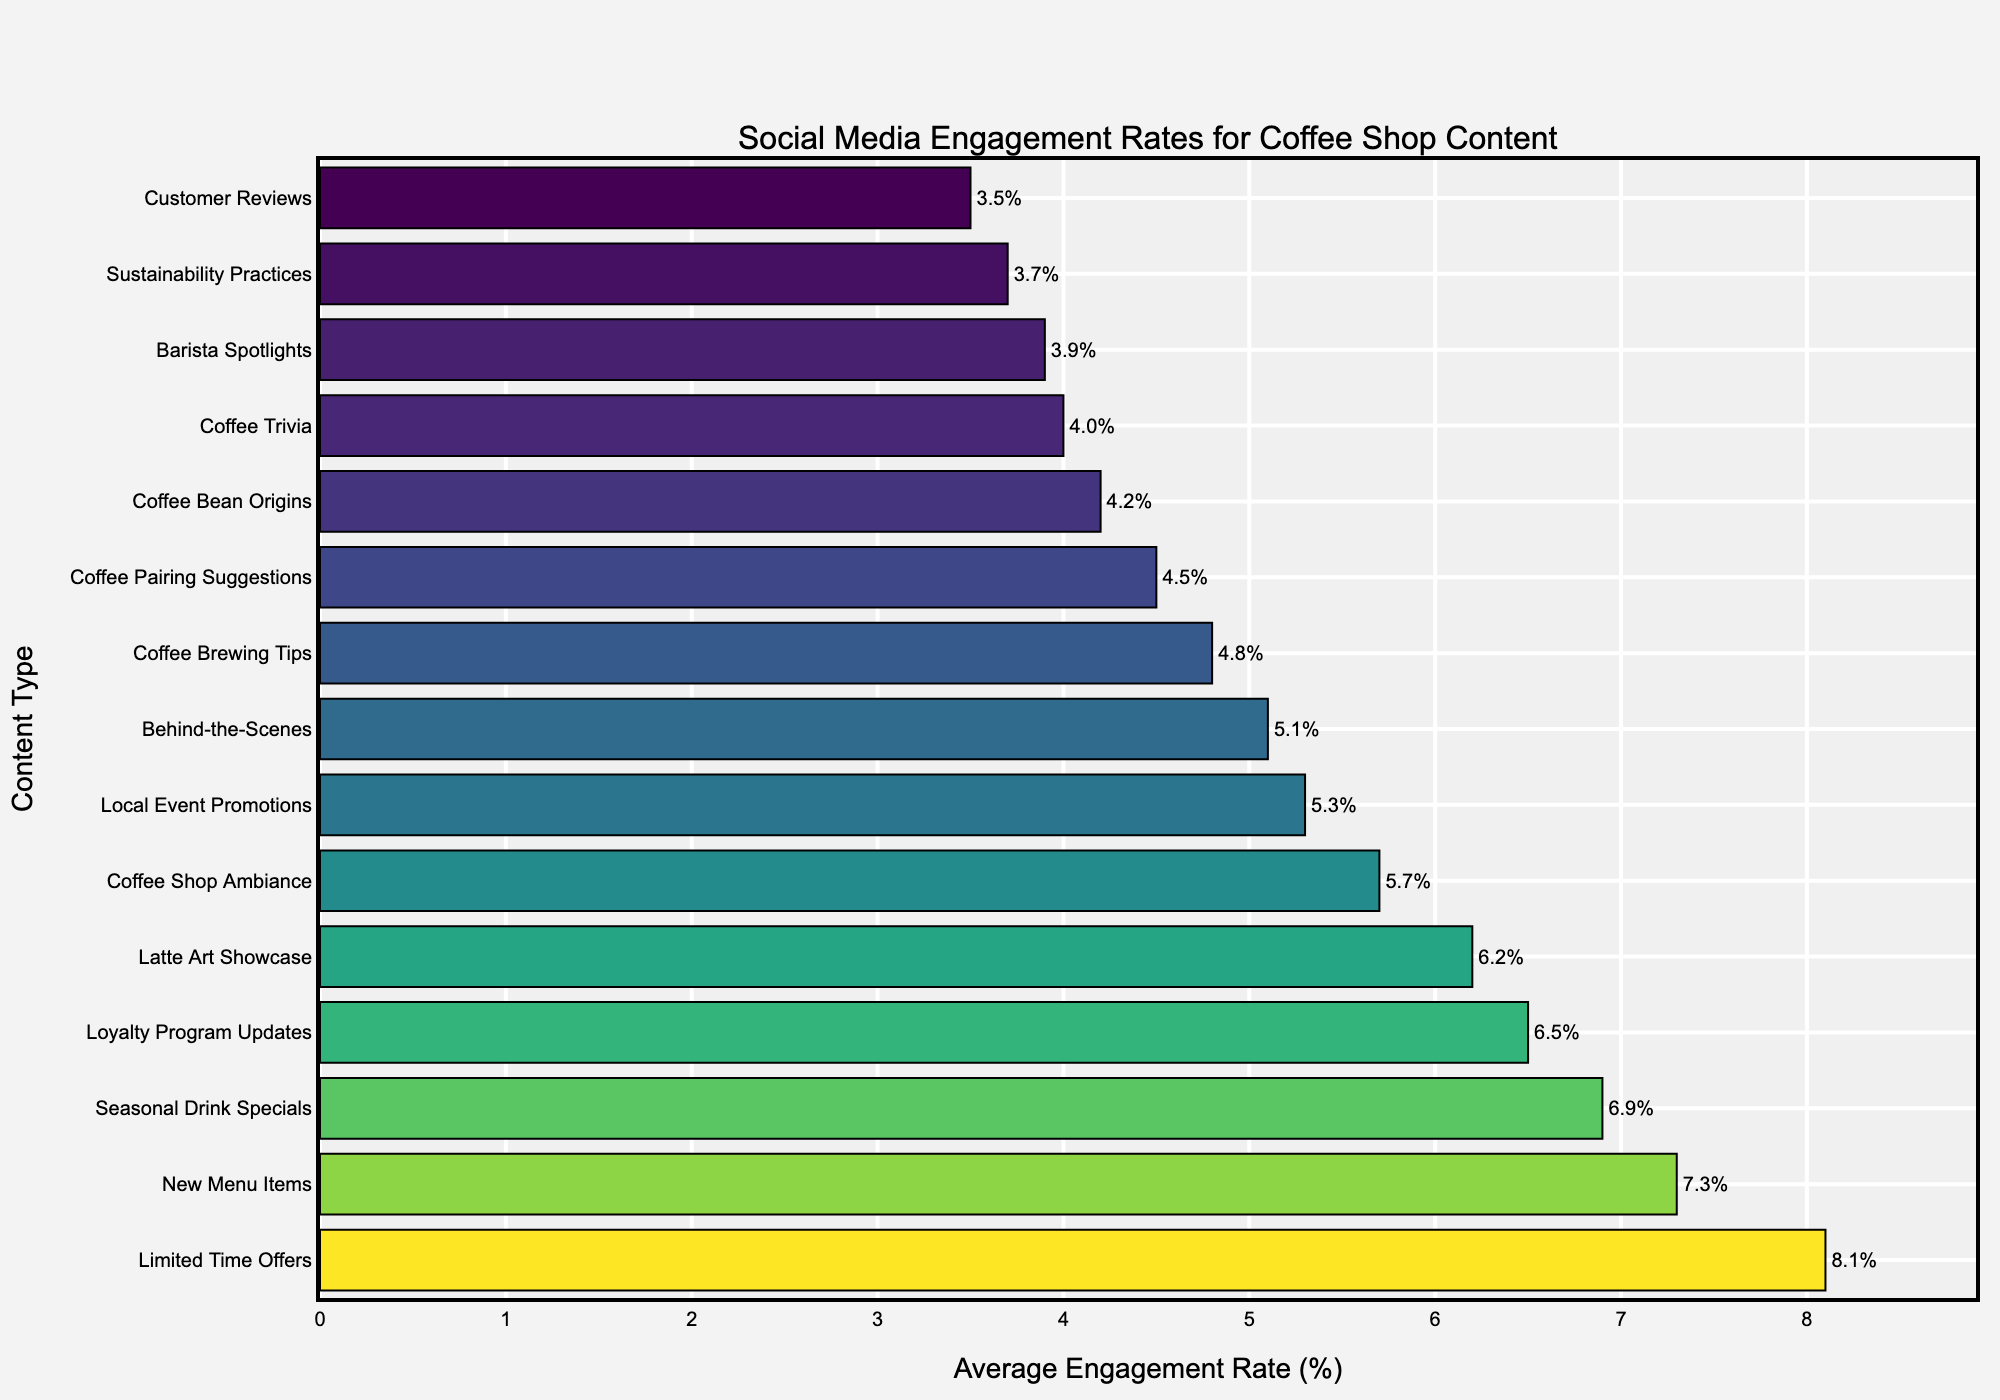What content type has the highest average engagement rate? The bar plot shows different content types on the y-axis with their corresponding average engagement rates on the x-axis. The highest bar represents the content type with the highest engagement rate.
Answer: Limited Time Offers What is the difference in average engagement rates between New Menu Items and Seasonal Drink Specials? Locate the bars for "New Menu Items" and "Seasonal Drink Specials" on the bar plot. Note their corresponding values (7.3% and 6.9% respectively). Subtract the lower value from the higher one (7.3 - 6.9).
Answer: 0.4% Which content type has a higher engagement rate: Barista Spotlights or Coffee Brewing Tips? Compare the heights of the two bars corresponding to "Barista Spotlights" and "Coffee Brewing Tips". "Coffee Brewing Tips" has a higher engagement rate (4.8%) compared to "Barista Spotlights" (3.9%).
Answer: Coffee Brewing Tips What are the average engagement rates for content types that promote products (New Menu Items and Limited Time Offers)? Identify the bars corresponding to "New Menu Items" and "Limited Time Offers" and note their engagement rates (7.3% and 8.1%). Sum these values and divide by 2 ( (7.3 + 8.1) / 2 ).
Answer: 7.7% Which content type received the lowest average engagement rate? The bar with the smallest corresponding value on the x-axis represents the content type with the lowest average engagement rate.
Answer: Customer Reviews How much greater is the average engagement rate of Coffee Shop Ambiance compared to Coffee Trivia? Identify the bars for "Coffee Shop Ambiance" (5.7%) and "Coffee Trivia" (4.0%). Subtract the engagement rate for "Coffee Trivia" from "Coffee Shop Ambiance" (5.7 - 4.0).
Answer: 1.7% Arrange the content types in descending order of their average engagement rates. Look at the bar plot and organize the content types by the height of their corresponding bars from tallest to shortest. The order is: Limited Time Offers (8.1%), New Menu Items (7.3%), Seasonal Drink Specials (6.9%), Loyalty Program Updates (6.5%), Latte Art Showcase (6.2%), Coffee Shop Ambiance (5.7%), Local Event Promotions (5.3%), Behind-the-Scenes (5.1%), Coffee Brewing Tips (4.8%), Coffee Pairing Suggestions (4.5%), Coffee Bean Origins (4.2%), Coffee Trivia (4.0%), Barista Spotlights (3.9%), Sustainability Practices (3.7%), Customer Reviews (3.5%).
Answer: Limited Time Offers, New Menu Items, Seasonal Drink Specials, Loyalty Program Updates, Latte Art Showcase, Coffee Shop Ambiance, Local Event Promotions, Behind-the-Scenes, Coffee Brewing Tips, Coffee Pairing Suggestions, Coffee Bean Origins, Coffee Trivia, Barista Spotlights, Sustainability Practices, Customer Reviews 